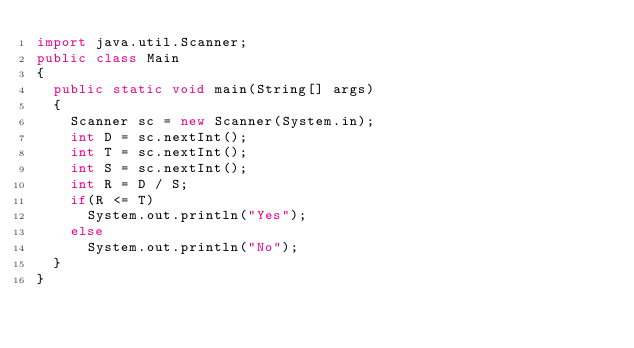Convert code to text. <code><loc_0><loc_0><loc_500><loc_500><_Java_>import java.util.Scanner;
public class Main
{
  public static void main(String[] args)
  {
    Scanner sc = new Scanner(System.in);
    int D = sc.nextInt();
    int T = sc.nextInt();
    int S = sc.nextInt();
    int R = D / S;
    if(R <= T)
      System.out.println("Yes");
    else
      System.out.println("No");
  }
}
</code> 